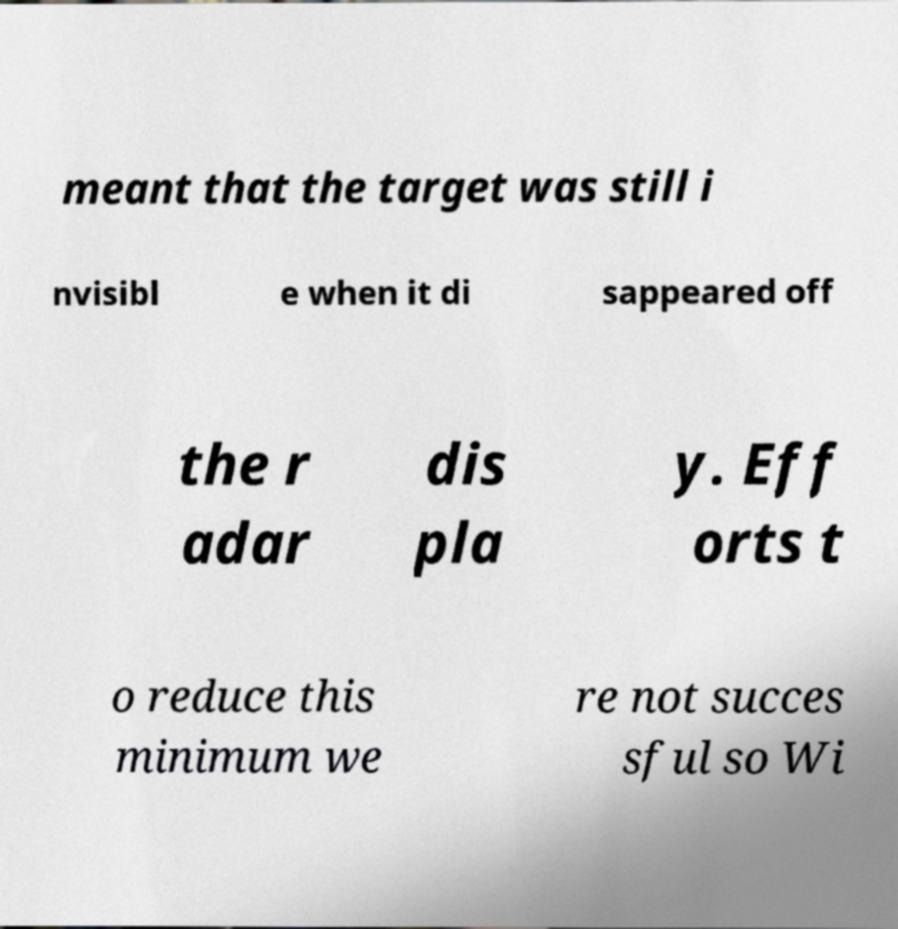Please read and relay the text visible in this image. What does it say? meant that the target was still i nvisibl e when it di sappeared off the r adar dis pla y. Eff orts t o reduce this minimum we re not succes sful so Wi 